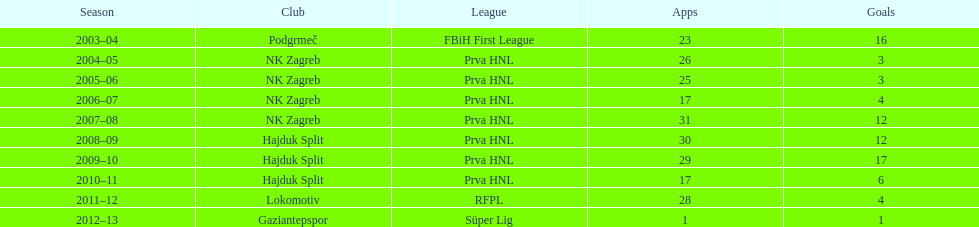Following his goal against bulgaria in zenica, ibricic also scored against this team in a 7-0 win in zenica less than a month after the non-competitive match against bulgaria. Estonia. 